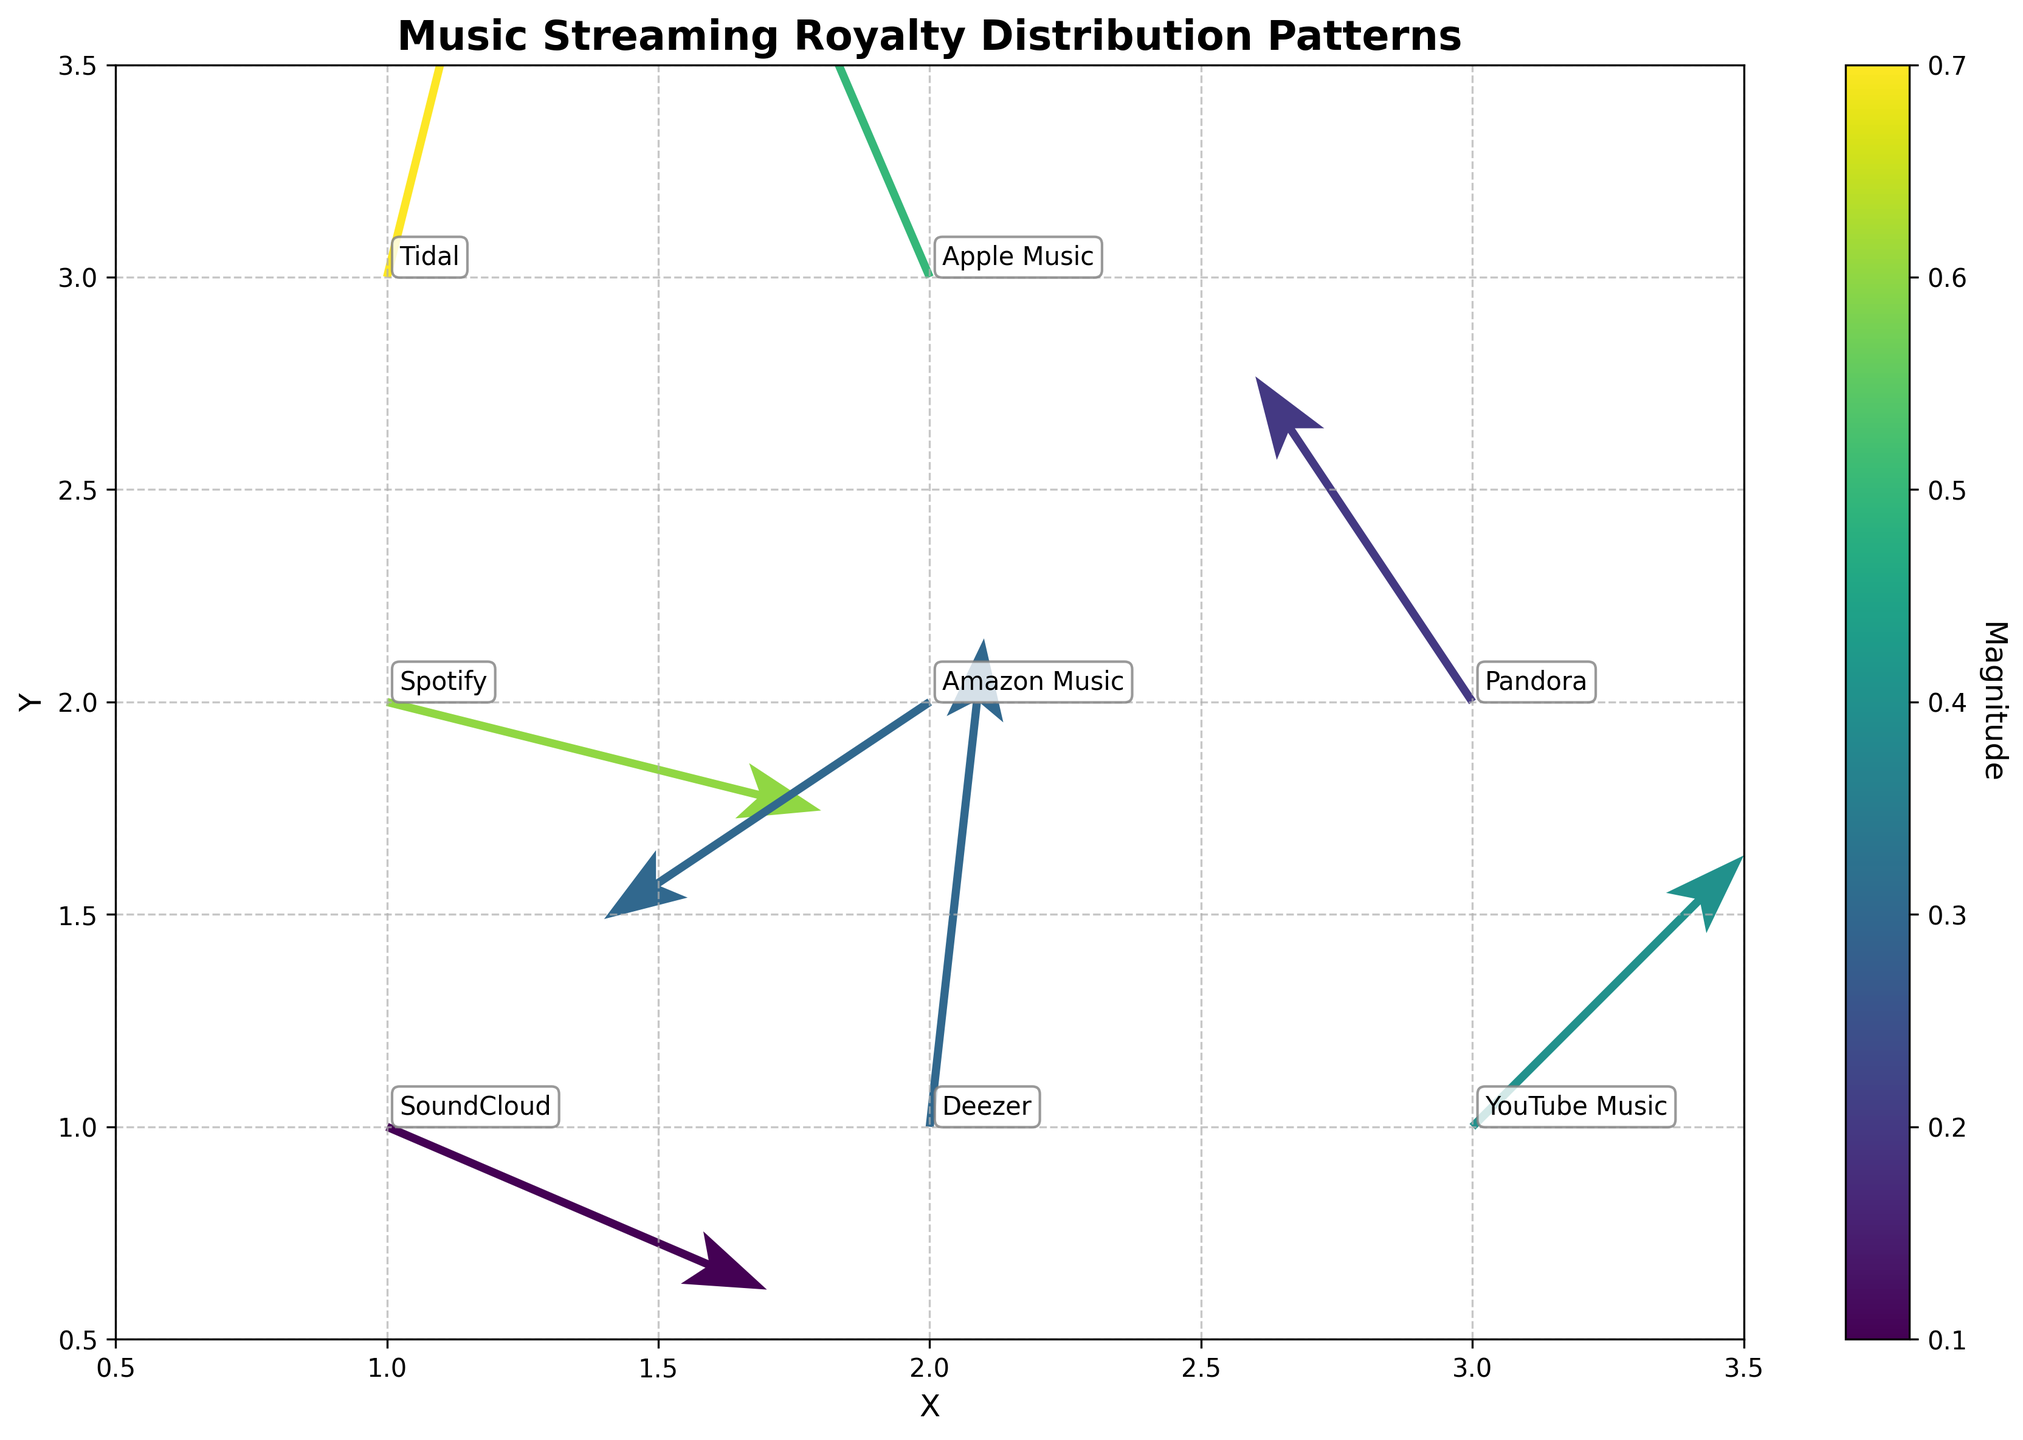What does the title of the figure indicate about the plot? The title "Music Streaming Royalty Distribution Patterns" suggests that the plot visualizes how royalties from different music streaming platforms are distributed, including both the direction and magnitude of payments.
Answer: Music Streaming Royalty Distribution Patterns What is the range of the 'Magnitude' shown in the colorbar? The colorbar, which uses various shades to represent 'Magnitude', typically ranges from the lowest to the highest values present in the data. By examining the actual plot, you can see these values.
Answer: 0.1 to 0.7 Which platform shows the highest magnitude in royalty distribution? Look for the longest arrow in the plot and match it with its corresponding label. Tidal has the highest magnitude as its arrow is the longest in the quiver plot.
Answer: Tidal Which platforms show a negative X-direction in their royalty payment distribution? Identify the arrows pointing to the left, which would have a negative X-direction, and match them with their labels. These platforms are Apple Music, Amazon Music, and Pandora.
Answer: Apple Music, Amazon Music, Pandora What is the direction of royalty payments for Spotify? Examine the direction of the arrow originating from Spotify in the plot. The arrow for Spotify points towards the right and slightly downward, indicating a positive X and a negative Y direction.
Answer: Right and slightly downward What is the average magnitude of royalty distribution across all platforms? Sum up all the magnitudes and divide by the number of platforms. The magnitudes are 0.6, 0.5, 0.4, 0.3, 0.7, 0.2, 0.1, and 0.3. Therefore, (0.6 + 0.5 + 0.4 + 0.3 + 0.7 + 0.2 + 0.1 + 0.3) / 8 = 3.1 / 8 = 0.3875.
Answer: 0.3875 Which platform has a unique combination of both positive X and Y directions, and what does this imply? Identify the platform whose arrow points upwards and to the right, implying both X and Y directions are positive. This platform is YouTube Music.
Answer: YouTube Music Compare the magnitude of royalty distribution for 'Apple Music' and 'Amazon Music'. Which is greater? Compare the lengths of the arrows for Apple Music and Amazon Music by their magnitudes. Apple's magnitude is 0.5 while Amazon’s is 0.3. The magnitude of royalty distribution for Apple Music is greater.
Answer: Apple Music Among all platforms, which one shows the highest positive Y-direction in its royalty payments? Look for the arrow with the highest upward direction and check its label. The platform with the highest positive Y-direction is Tidal.
Answer: Tidal 